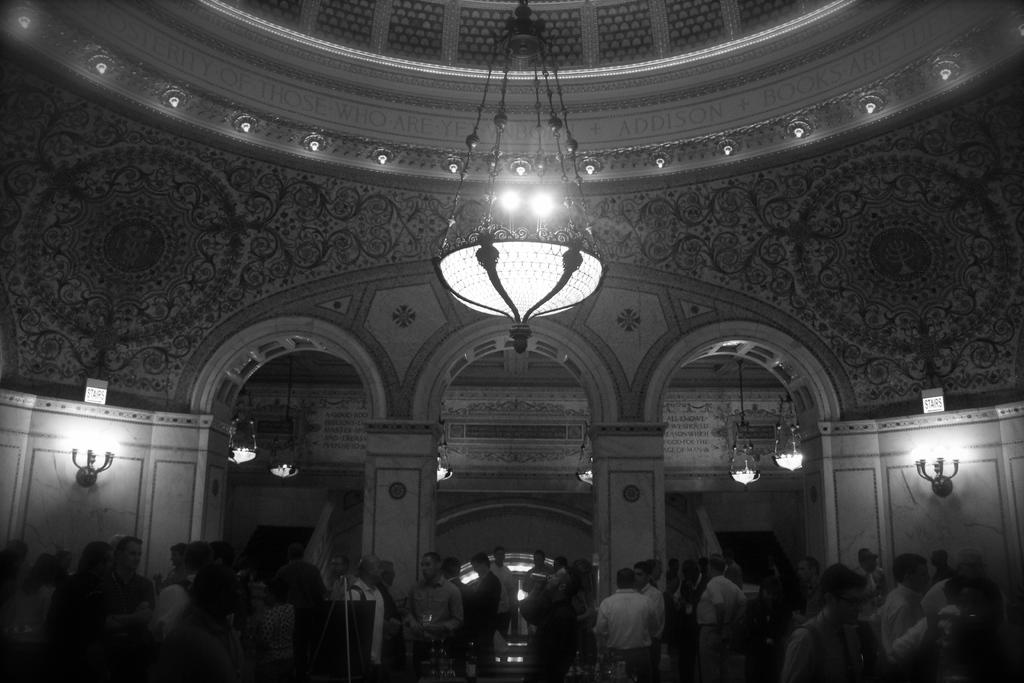What is the color scheme of the image? The image is black and white. Where was the image taken? The image was taken inside a building. Can you describe the people in the image? There are many people at the bottom of the image. What type of flowers can be seen in the image? There are no flowers present in the image, as it is a black and white image taken inside a building. 